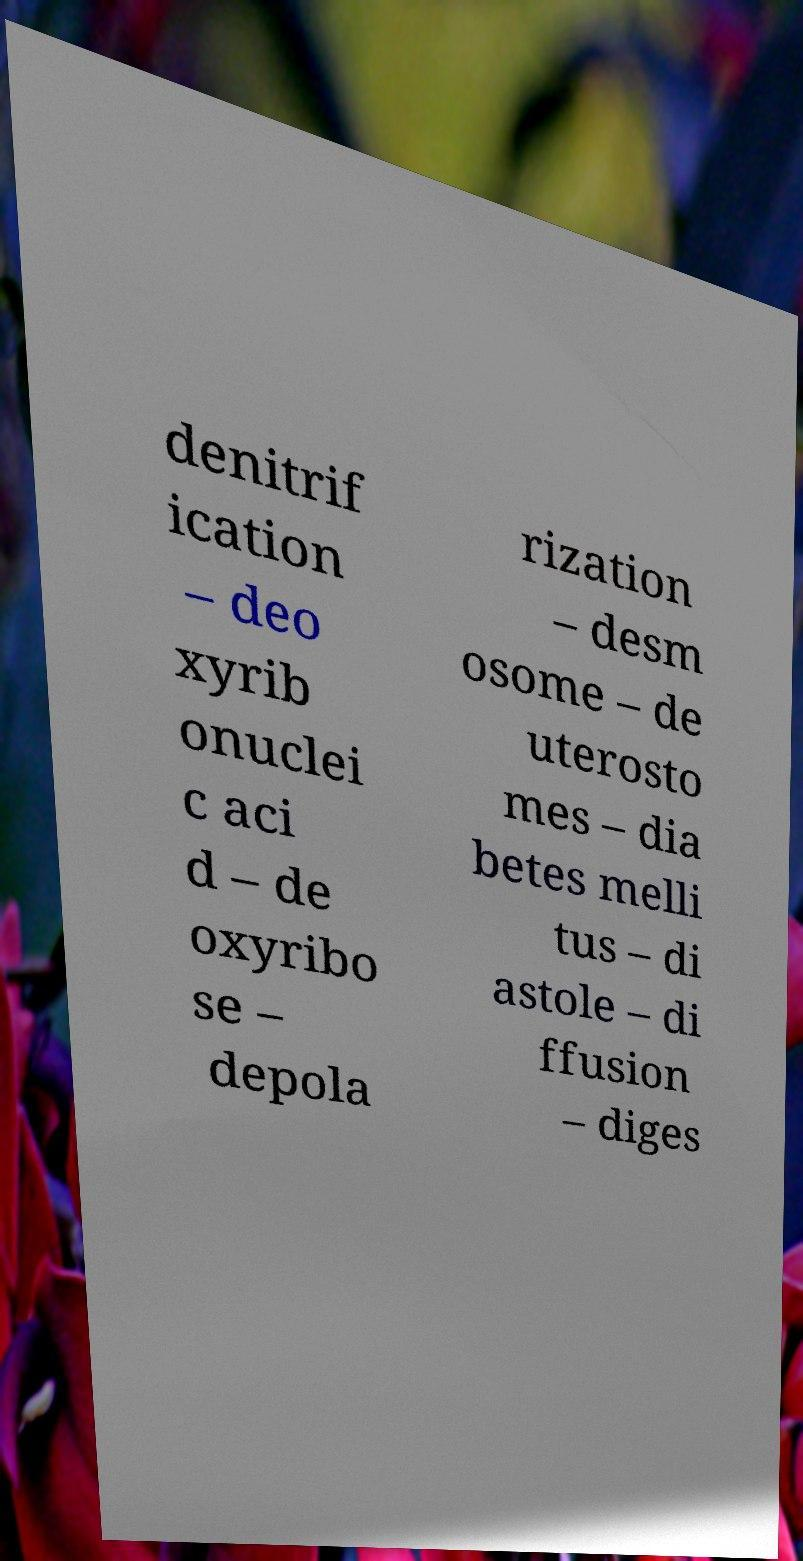Can you accurately transcribe the text from the provided image for me? denitrif ication – deo xyrib onuclei c aci d – de oxyribo se – depola rization – desm osome – de uterosto mes – dia betes melli tus – di astole – di ffusion – diges 